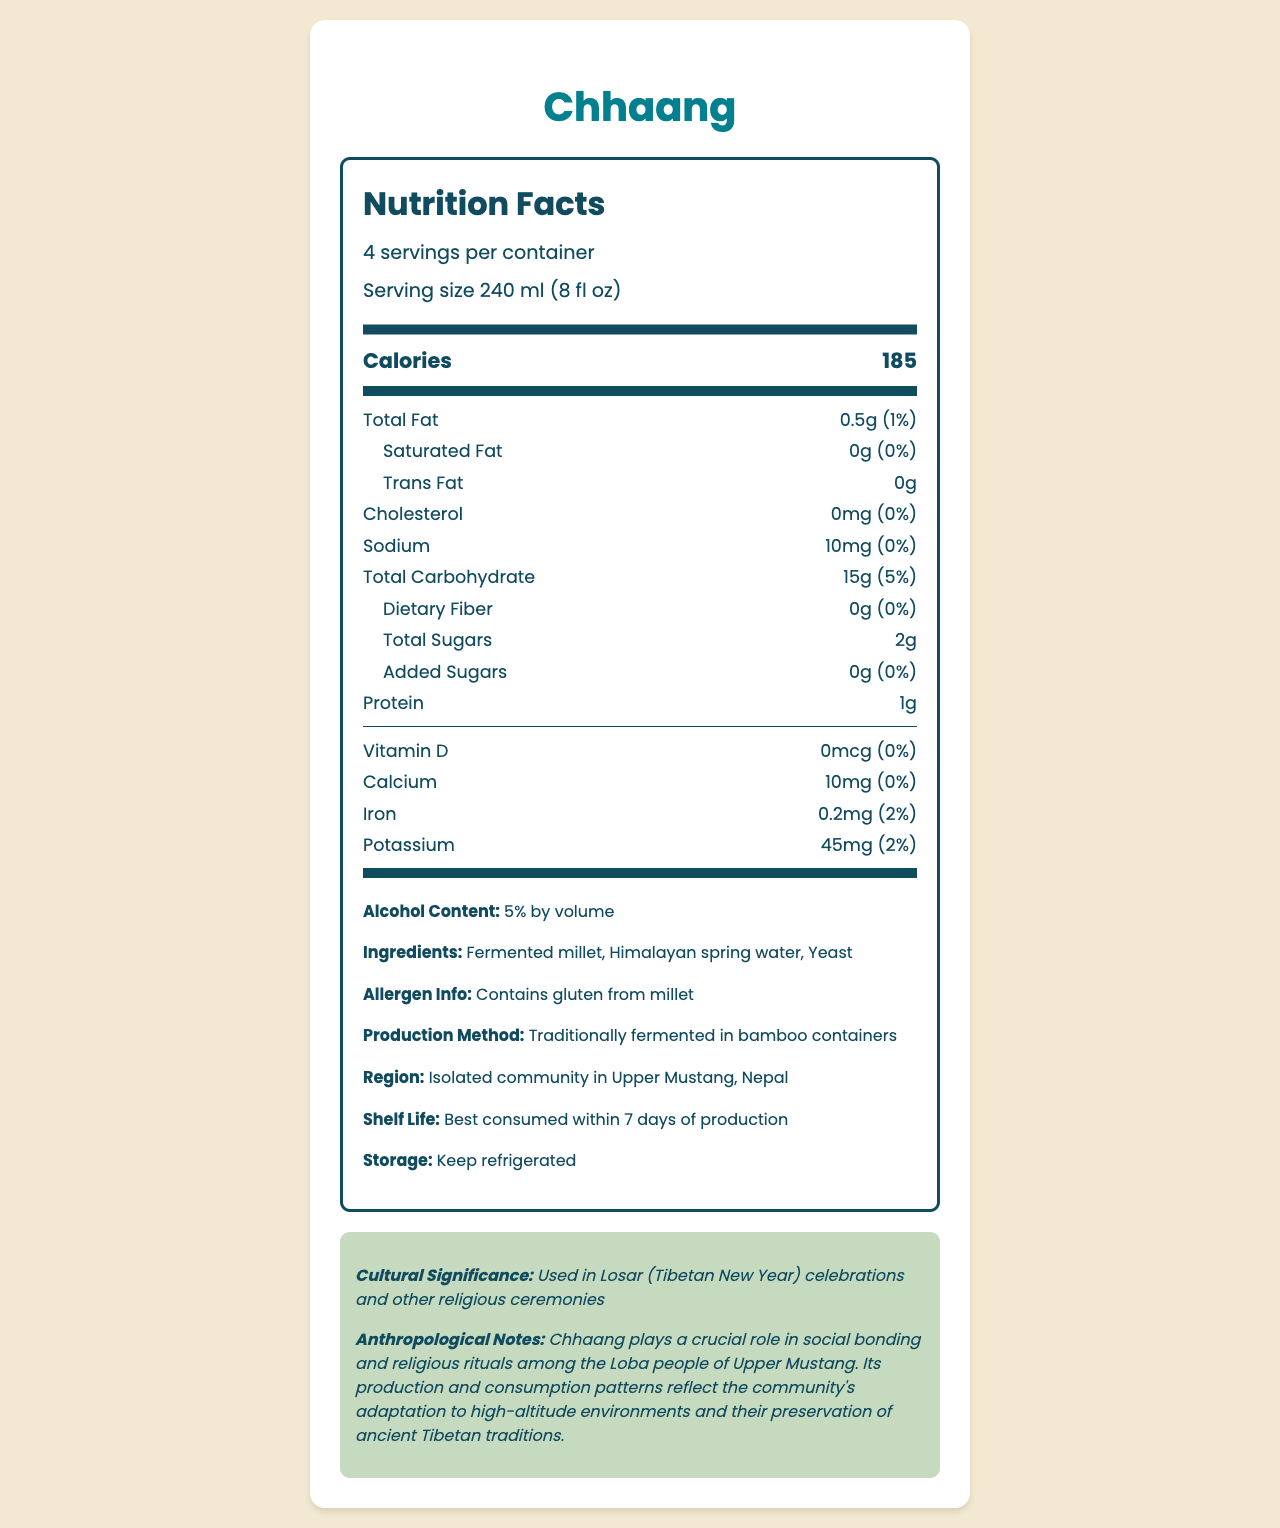what is the serving size for Chhaang? The serving size is explicitly stated in the nutrition label: "Serving size 240 ml (8 fl oz)."
Answer: 240 ml (8 fl oz) how many calories are there per serving of Chhaang? The calories per serving is given as "Calories 185" in the nutrition label.
Answer: 185 what is the total carbohydrate content per serving of Chhaang? The total carbohydrate content per serving is labeled as "Total Carbohydrate 15g (5%)."
Answer: 15g Does Chhaang contain saturated fat? The nutrition facts state "Saturated Fat 0g (0%)." This indicates that there is no saturated fat.
Answer: No how much protein is in each serving of Chhaang? The amount of protein per serving is stated as "Protein 1g."
Answer: 1g In which region is Chhaang traditionally produced? A. Central Nepal B. Upper Mustang, Nepal C. Kathmandu Valley D. Southern Tibet The nutrition label states that Chhaang is from "Upper Mustang, Nepal."
Answer: B what are the ingredients of Chhaang? A. Rice and Water B. Barley and Yeast C. Fermented Millet, Himalayan Spring Water, and Yeast The listed ingredients are "Fermented millet, Himalayan spring water, Yeast."
Answer: C Is the consumption of Chhaang associated with any cultural significance? The document mentions that "Chhaang plays a crucial role in social bonding and religious rituals among the Loba people of Upper Mustang."
Answer: Yes Is Chhaang gluten-free? The allergen information states "Contains gluten from millet."
Answer: No summarize the nutrition facts of Chhaang and its cultural significance. The Chhaang nutrition label highlights its primary nutrients and emphasizes its cultural significance in religious practices amongst the Loba people.
Answer: Chhaang is a fermented beverage from Upper Mustang, Nepal, typically used in religious ceremonies. Each 240 ml serving contains 185 calories, 0.5g of total fat, 15g of carbohydrates, 2g of sugars, and 1g of protein. There are minimal vitamins and minerals present. Chhaang contains 5% alcohol by volume and is made from fermented millet, Himalayan spring water, and yeast. It contains gluten and is traditionally fermented in bamboo containers. It plays an important role in the cultural and religious practices of the Loba people. how many servings are in one container of Chhaang? The label states "4 servings per container."
Answer: 4 what is the alcohol content of Chhaang by volume? The alcohol content is indicated as "Alcohol Content: 5% by volume."
Answer: 5% Can the shelf life of Chhaang be extended by keeping it at room temperature? The storage instructions mention that Chhaang should be kept refrigerated, implying that room temperature storage is not suitable.
Answer: No Does the Chhaang contain any added sugars? It is specified that there are "0g" of added sugars.
Answer: No who are the primary cultural consumers of Chhaang? The document states that Chhaang is integral to the social and religious practices of the Loba people of Upper Mustang.
Answer: The Loba people of Upper Mustang what percentage of the daily value of iron is provided by one serving of Chhaang? The iron content in the document is stated as "Iron 0.2mg (2%)."
Answer: 2% What are the mineral contents of Chhaang? The minerals listed in the document are calcium, iron, and potassium.
Answer: Calcium: 10mg, Iron: 0.2mg, Potassium: 45mg Are there any sugars in Chhaang? The document specifies "Total Sugars: 2g."
Answer: Yes how is Chhaang traditionally produced? The document states that Chhaang is "traditionally fermented in bamboo containers."
Answer: Fermented in bamboo containers Does Chhaang contribute significantly to dietary fiber intake? The dietary fiber content is "0g (0%)," indicating it does not contribute to dietary fiber intake.
Answer: No what is the exact production method used for fermenting Chhaang? While the document states that Chhaang is fermented in bamboo containers, it does not provide the detailed, step-by-step process required for fermentation.
Answer: Not enough information 